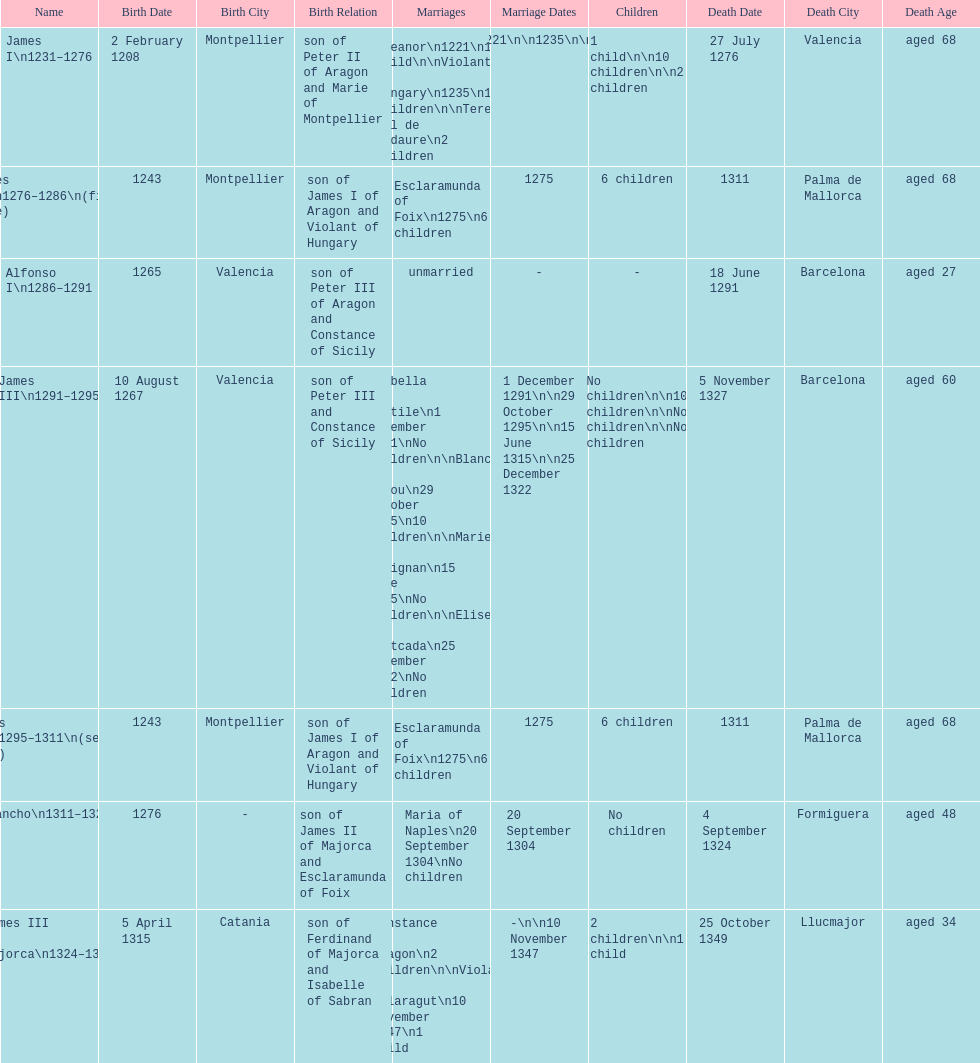How long was james ii in power, including his second rule? 26 years. 